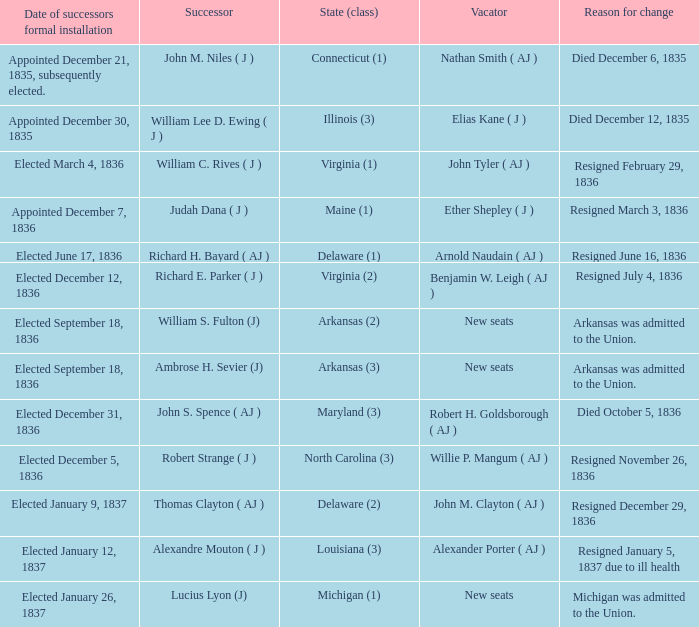Name the successor for elected january 26, 1837 1.0. 